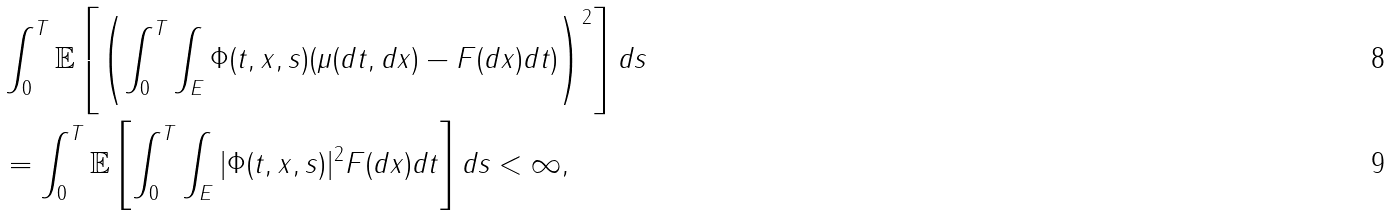<formula> <loc_0><loc_0><loc_500><loc_500>& \int _ { 0 } ^ { T } \mathbb { E } \left [ \left ( \int _ { 0 } ^ { T } \int _ { E } \Phi ( t , x , s ) ( \mu ( d t , d x ) - F ( d x ) d t ) \right ) ^ { 2 } \right ] d s \\ & = \int _ { 0 } ^ { T } \mathbb { E } \left [ \int _ { 0 } ^ { T } \int _ { E } | \Phi ( t , x , s ) | ^ { 2 } F ( d x ) d t \right ] d s < \infty ,</formula> 